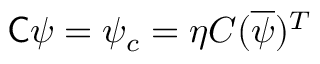Convert formula to latex. <formula><loc_0><loc_0><loc_500><loc_500>{ C } \psi = \psi _ { c } = \eta C ( { \overline { \psi } } ) ^ { T }</formula> 